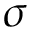Convert formula to latex. <formula><loc_0><loc_0><loc_500><loc_500>\sigma</formula> 